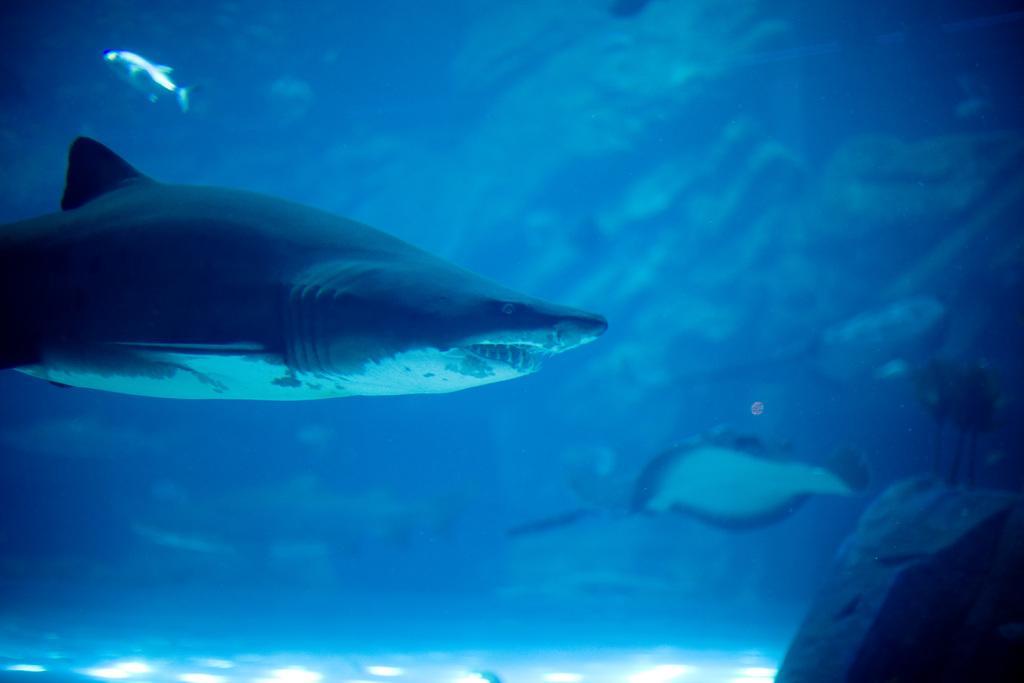Please provide a concise description of this image. In this image I can see two fishes and water. This fish is facing towards the right side. On the bottom right corner of the image I can see rock. 